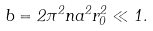<formula> <loc_0><loc_0><loc_500><loc_500>b = 2 \pi ^ { 2 } n a ^ { 2 } r _ { 0 } ^ { 2 } \ll 1 .</formula> 